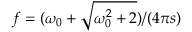Convert formula to latex. <formula><loc_0><loc_0><loc_500><loc_500>f = ( \omega _ { 0 } + \sqrt { \omega _ { 0 } ^ { 2 } + 2 } ) / ( 4 \pi s )</formula> 